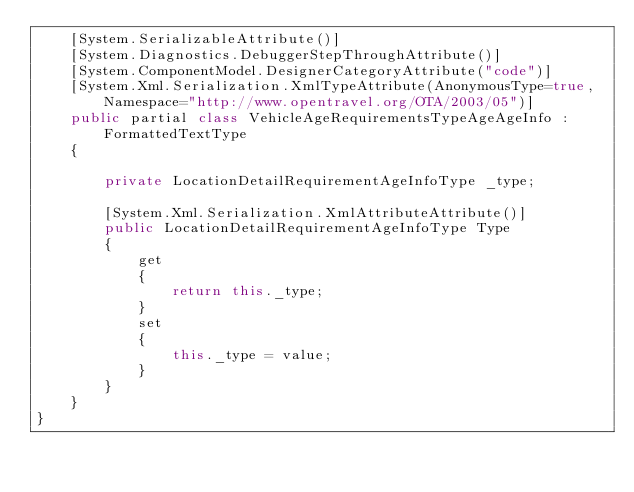Convert code to text. <code><loc_0><loc_0><loc_500><loc_500><_C#_>    [System.SerializableAttribute()]
    [System.Diagnostics.DebuggerStepThroughAttribute()]
    [System.ComponentModel.DesignerCategoryAttribute("code")]
    [System.Xml.Serialization.XmlTypeAttribute(AnonymousType=true, Namespace="http://www.opentravel.org/OTA/2003/05")]
    public partial class VehicleAgeRequirementsTypeAgeAgeInfo : FormattedTextType
    {
        
        private LocationDetailRequirementAgeInfoType _type;
        
        [System.Xml.Serialization.XmlAttributeAttribute()]
        public LocationDetailRequirementAgeInfoType Type
        {
            get
            {
                return this._type;
            }
            set
            {
                this._type = value;
            }
        }
    }
}</code> 